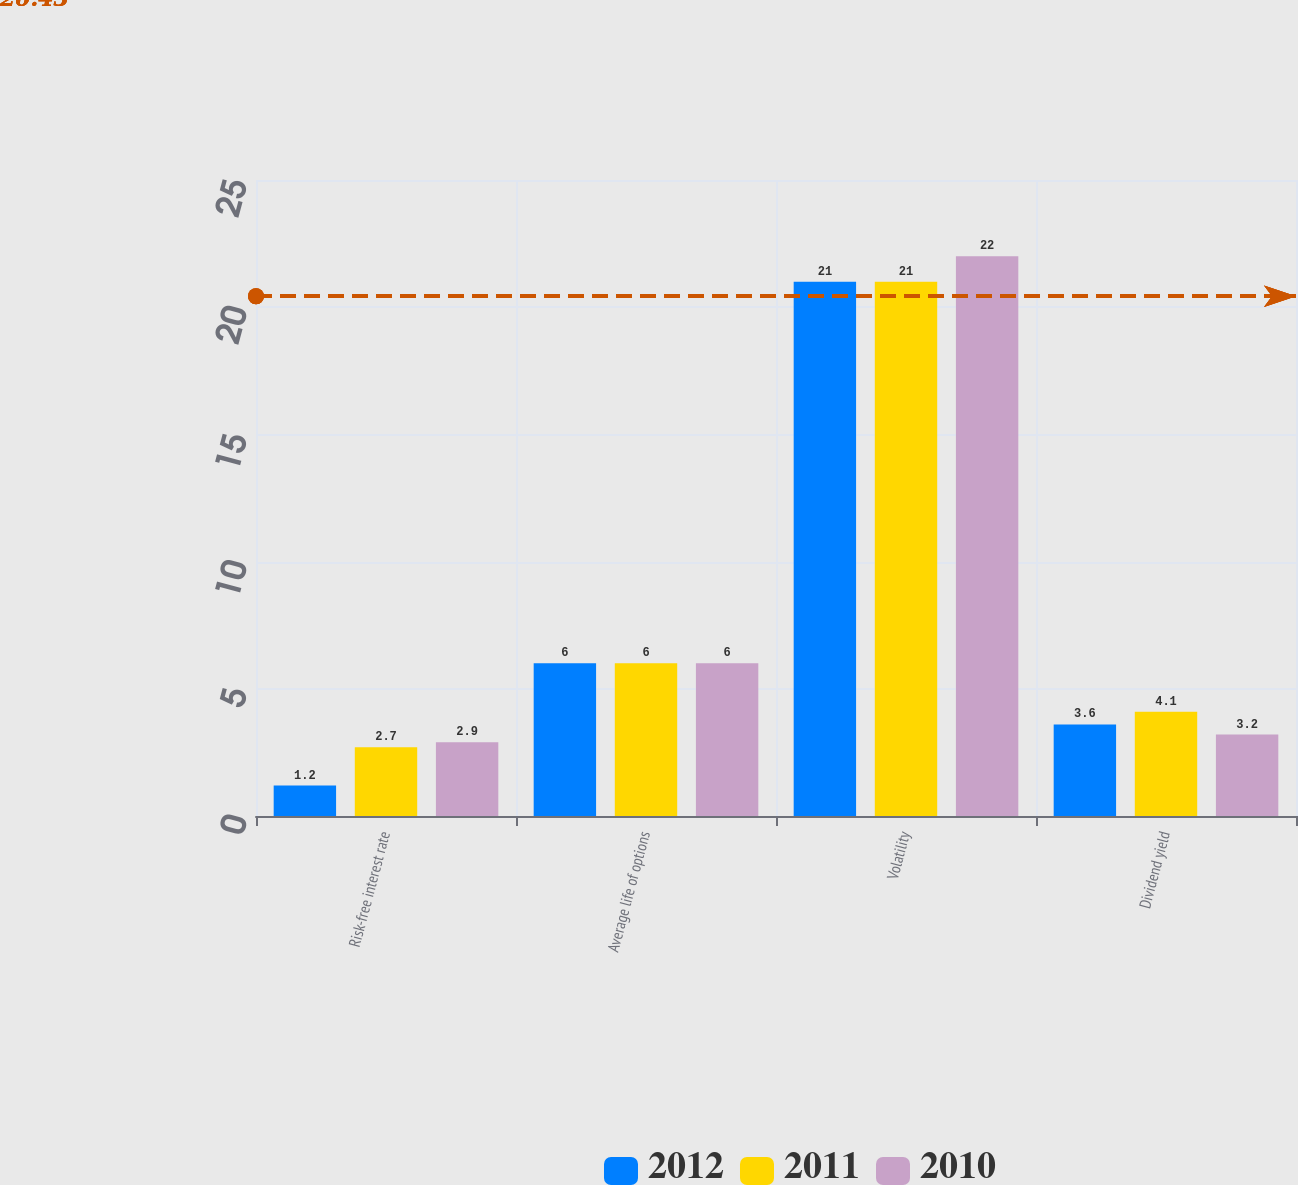Convert chart to OTSL. <chart><loc_0><loc_0><loc_500><loc_500><stacked_bar_chart><ecel><fcel>Risk-free interest rate<fcel>Average life of options<fcel>Volatility<fcel>Dividend yield<nl><fcel>2012<fcel>1.2<fcel>6<fcel>21<fcel>3.6<nl><fcel>2011<fcel>2.7<fcel>6<fcel>21<fcel>4.1<nl><fcel>2010<fcel>2.9<fcel>6<fcel>22<fcel>3.2<nl></chart> 